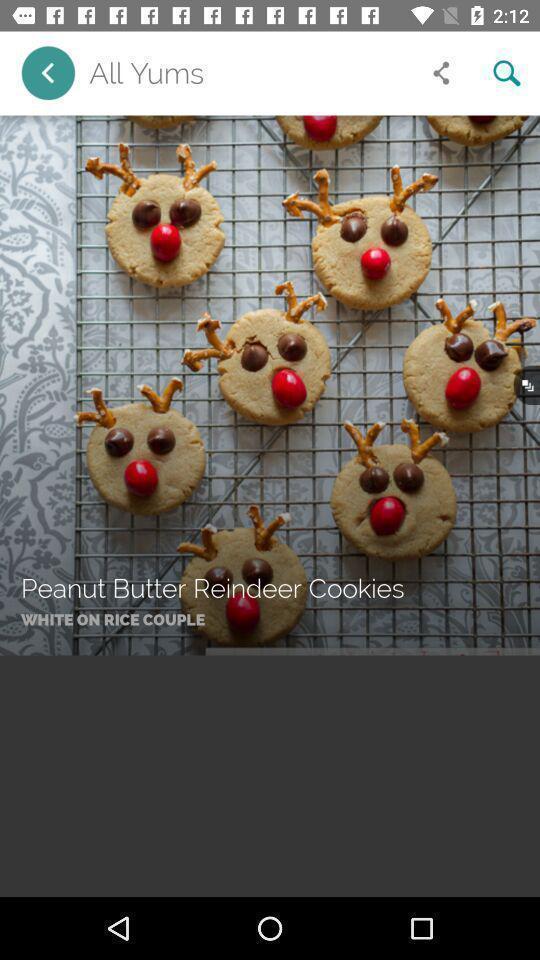Describe the content in this image. Page showing image of cookies in cookies making app. 